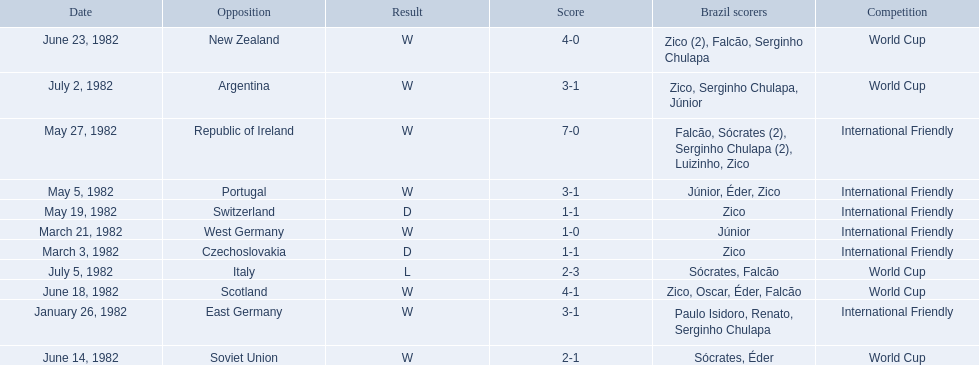Who did brazil play against Soviet Union. Who scored the most goals? Portugal. 